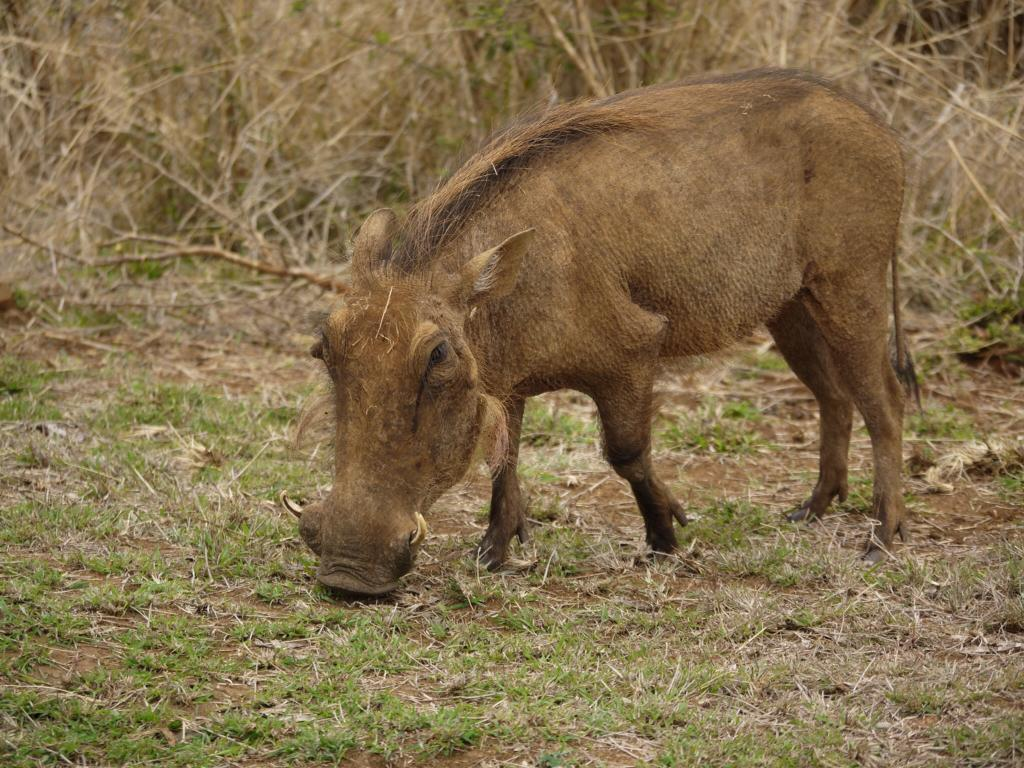What animal is featured in the image? There is a warthog in the image. What type of vegetation is present at the bottom of the image? Grass is present at the bottom of the image. Can you describe the background of the image? Grass and a stick are visible in the background of the image. What is the warthog arguing about with the cactus in the image? There is no cactus present in the image, and therefore no argument can be observed. 